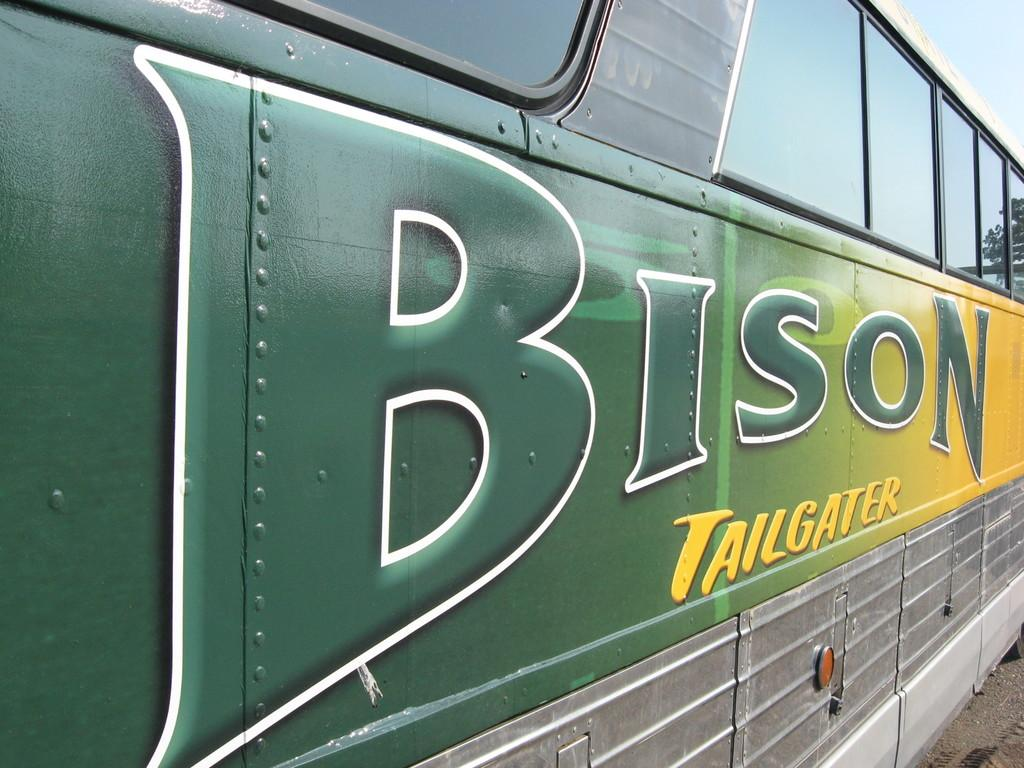<image>
Provide a brief description of the given image. A bus noted as being for Bison tailgaters. 